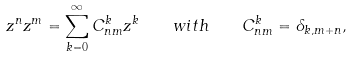<formula> <loc_0><loc_0><loc_500><loc_500>z ^ { n } z ^ { m } = \sum _ { k = 0 } ^ { \infty } C _ { n m } ^ { k } z ^ { k } \quad w i t h \quad C _ { n m } ^ { k } = \delta _ { k , m + n } ,</formula> 